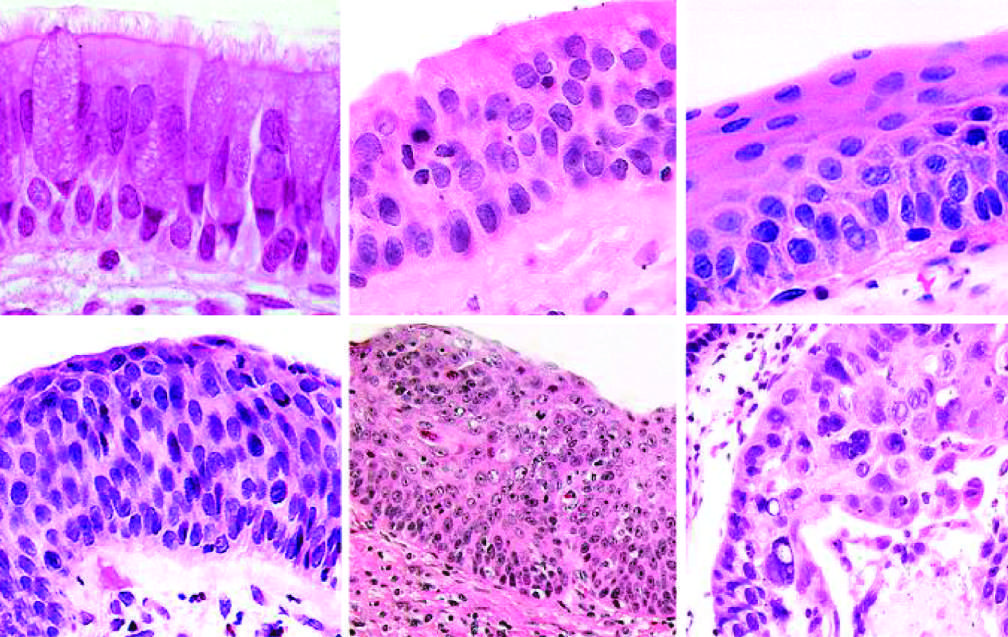what do more ominous changes include?
Answer the question using a single word or phrase. The appearance of squamous dysplasia 